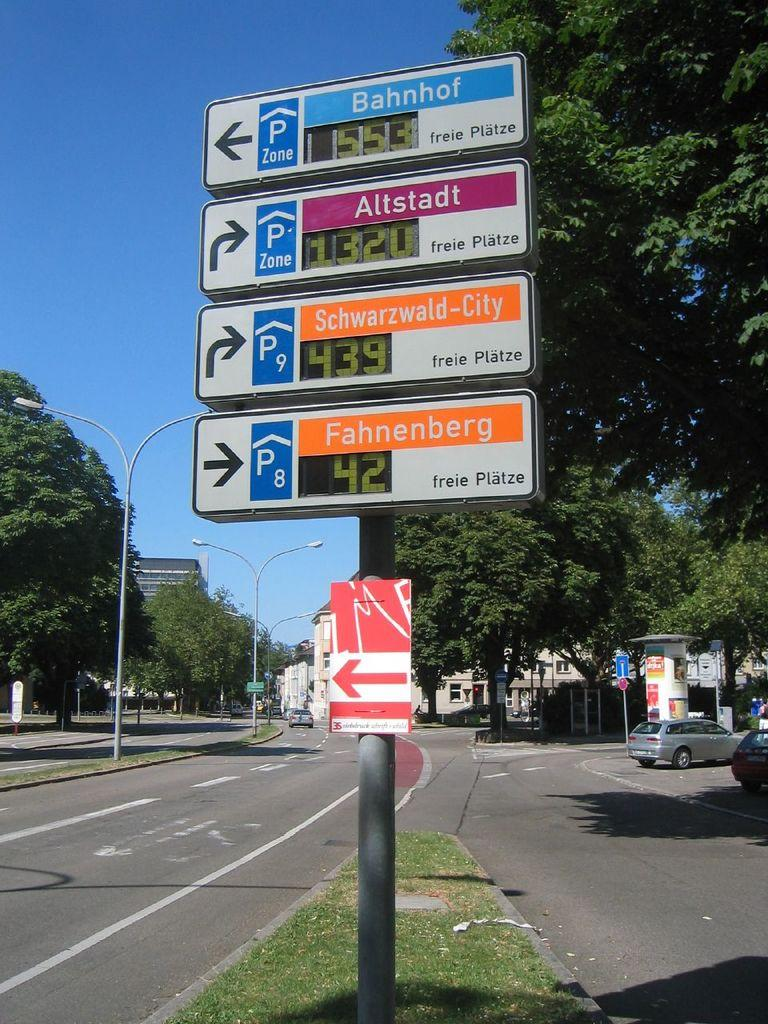<image>
Provide a brief description of the given image. A sign on the side of the road shows how far to a parking zone at Bahnhof. 